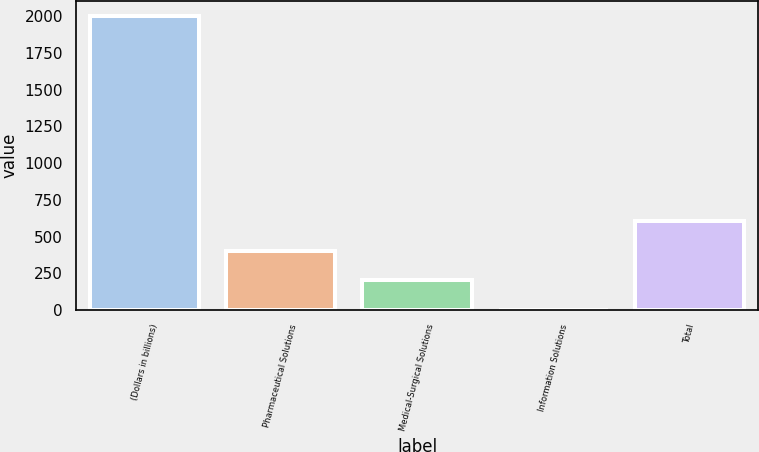<chart> <loc_0><loc_0><loc_500><loc_500><bar_chart><fcel>(Dollars in billions)<fcel>Pharmaceutical Solutions<fcel>Medical-Surgical Solutions<fcel>Information Solutions<fcel>Total<nl><fcel>2004<fcel>402.4<fcel>202.2<fcel>2<fcel>602.6<nl></chart> 